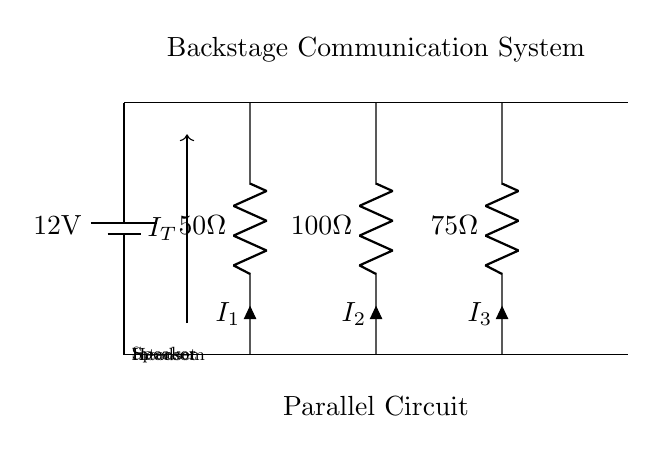What is the voltage of the power supply? The voltage indicated in the circuit is 12 volts, as shown by the battery symbol labeled as 12V.
Answer: 12 volts What are the three main components in this circuit? The main components are the intercom, headset, and speaker, as identified by their respective resistor labels.
Answer: Intercom, headset, speaker What is the resistance value of the headset? The resistance value of the headset is 100 ohms, based on the label next to the headset component in the diagram.
Answer: 100 ohms What is the total current flowing in the circuit? The total current, represented by \( I_T \), would be the sum of the individual currents through each parallel component, but it isn't given directly in the circuit diagram.
Answer: Not specified How are the components connected in this circuit? The components are connected in parallel, meaning that they share the same voltage across them, which facilitates simultaneous operation of intercom, headset, and speaker.
Answer: Parallel What happens to the total current if one component fails? In a parallel circuit, if one component fails, the total current will decrease, but the remaining components will continue to operate as they still have the same voltage supply.
Answer: Decrease 